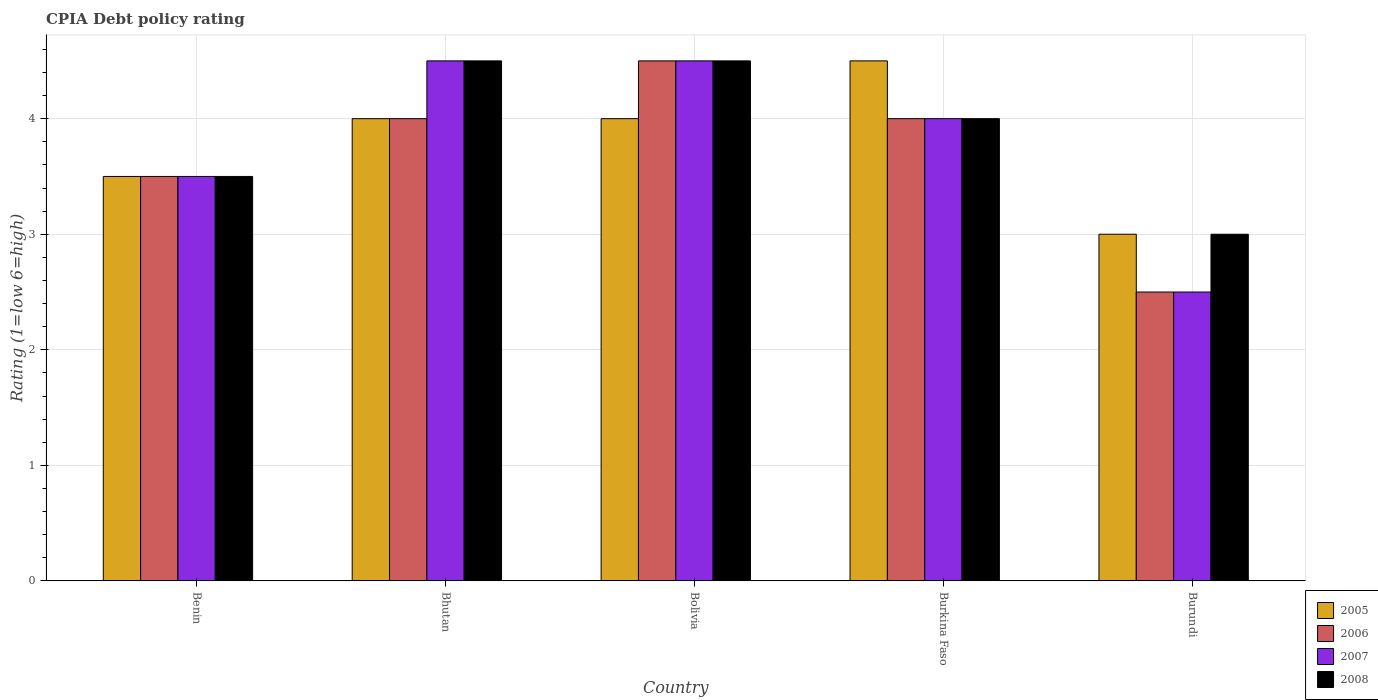How many different coloured bars are there?
Keep it short and to the point. 4. How many bars are there on the 4th tick from the right?
Provide a short and direct response. 4. What is the label of the 2nd group of bars from the left?
Ensure brevity in your answer.  Bhutan. What is the CPIA rating in 2007 in Bolivia?
Give a very brief answer. 4.5. Across all countries, what is the minimum CPIA rating in 2006?
Provide a short and direct response. 2.5. In which country was the CPIA rating in 2005 maximum?
Provide a short and direct response. Burkina Faso. In which country was the CPIA rating in 2008 minimum?
Your answer should be very brief. Burundi. What is the difference between the CPIA rating in 2005 in Bolivia and the CPIA rating in 2007 in Bhutan?
Keep it short and to the point. -0.5. In how many countries, is the CPIA rating in 2006 greater than 4.4?
Your response must be concise. 1. Is the sum of the CPIA rating in 2007 in Bolivia and Burkina Faso greater than the maximum CPIA rating in 2006 across all countries?
Offer a very short reply. Yes. What does the 4th bar from the left in Bhutan represents?
Ensure brevity in your answer.  2008. What does the 1st bar from the right in Bhutan represents?
Offer a very short reply. 2008. Is it the case that in every country, the sum of the CPIA rating in 2006 and CPIA rating in 2008 is greater than the CPIA rating in 2005?
Make the answer very short. Yes. Are all the bars in the graph horizontal?
Your answer should be very brief. No. How many countries are there in the graph?
Your answer should be compact. 5. Does the graph contain grids?
Ensure brevity in your answer.  Yes. Where does the legend appear in the graph?
Give a very brief answer. Bottom right. How many legend labels are there?
Offer a terse response. 4. How are the legend labels stacked?
Offer a very short reply. Vertical. What is the title of the graph?
Offer a very short reply. CPIA Debt policy rating. What is the label or title of the Y-axis?
Offer a very short reply. Rating (1=low 6=high). What is the Rating (1=low 6=high) of 2006 in Bhutan?
Your answer should be compact. 4. What is the Rating (1=low 6=high) in 2006 in Bolivia?
Your answer should be very brief. 4.5. What is the Rating (1=low 6=high) of 2007 in Bolivia?
Your answer should be very brief. 4.5. What is the Rating (1=low 6=high) of 2007 in Burkina Faso?
Your answer should be very brief. 4. What is the Rating (1=low 6=high) of 2008 in Burkina Faso?
Ensure brevity in your answer.  4. What is the Rating (1=low 6=high) in 2005 in Burundi?
Keep it short and to the point. 3. What is the Rating (1=low 6=high) in 2006 in Burundi?
Keep it short and to the point. 2.5. What is the Rating (1=low 6=high) in 2008 in Burundi?
Give a very brief answer. 3. Across all countries, what is the maximum Rating (1=low 6=high) in 2007?
Make the answer very short. 4.5. Across all countries, what is the maximum Rating (1=low 6=high) of 2008?
Give a very brief answer. 4.5. Across all countries, what is the minimum Rating (1=low 6=high) in 2008?
Ensure brevity in your answer.  3. What is the total Rating (1=low 6=high) of 2005 in the graph?
Your response must be concise. 19. What is the total Rating (1=low 6=high) in 2006 in the graph?
Your answer should be compact. 18.5. What is the total Rating (1=low 6=high) of 2007 in the graph?
Provide a short and direct response. 19. What is the total Rating (1=low 6=high) in 2008 in the graph?
Give a very brief answer. 19.5. What is the difference between the Rating (1=low 6=high) in 2005 in Benin and that in Bhutan?
Ensure brevity in your answer.  -0.5. What is the difference between the Rating (1=low 6=high) of 2006 in Benin and that in Bhutan?
Give a very brief answer. -0.5. What is the difference between the Rating (1=low 6=high) in 2007 in Benin and that in Bhutan?
Provide a short and direct response. -1. What is the difference between the Rating (1=low 6=high) in 2007 in Benin and that in Bolivia?
Offer a very short reply. -1. What is the difference between the Rating (1=low 6=high) of 2006 in Benin and that in Burkina Faso?
Your answer should be compact. -0.5. What is the difference between the Rating (1=low 6=high) in 2008 in Benin and that in Burkina Faso?
Offer a terse response. -0.5. What is the difference between the Rating (1=low 6=high) of 2007 in Benin and that in Burundi?
Ensure brevity in your answer.  1. What is the difference between the Rating (1=low 6=high) in 2007 in Bhutan and that in Bolivia?
Your response must be concise. 0. What is the difference between the Rating (1=low 6=high) of 2008 in Bhutan and that in Bolivia?
Provide a short and direct response. 0. What is the difference between the Rating (1=low 6=high) in 2005 in Bhutan and that in Burkina Faso?
Make the answer very short. -0.5. What is the difference between the Rating (1=low 6=high) in 2006 in Bhutan and that in Burkina Faso?
Your answer should be very brief. 0. What is the difference between the Rating (1=low 6=high) of 2005 in Bhutan and that in Burundi?
Your answer should be compact. 1. What is the difference between the Rating (1=low 6=high) of 2006 in Bhutan and that in Burundi?
Ensure brevity in your answer.  1.5. What is the difference between the Rating (1=low 6=high) of 2005 in Bolivia and that in Burkina Faso?
Offer a very short reply. -0.5. What is the difference between the Rating (1=low 6=high) of 2008 in Bolivia and that in Burkina Faso?
Your answer should be compact. 0.5. What is the difference between the Rating (1=low 6=high) of 2005 in Bolivia and that in Burundi?
Provide a succinct answer. 1. What is the difference between the Rating (1=low 6=high) in 2006 in Bolivia and that in Burundi?
Your answer should be compact. 2. What is the difference between the Rating (1=low 6=high) of 2005 in Benin and the Rating (1=low 6=high) of 2006 in Bhutan?
Make the answer very short. -0.5. What is the difference between the Rating (1=low 6=high) of 2005 in Benin and the Rating (1=low 6=high) of 2008 in Bhutan?
Make the answer very short. -1. What is the difference between the Rating (1=low 6=high) in 2006 in Benin and the Rating (1=low 6=high) in 2008 in Bhutan?
Ensure brevity in your answer.  -1. What is the difference between the Rating (1=low 6=high) of 2007 in Benin and the Rating (1=low 6=high) of 2008 in Bhutan?
Your answer should be very brief. -1. What is the difference between the Rating (1=low 6=high) of 2005 in Benin and the Rating (1=low 6=high) of 2007 in Bolivia?
Your answer should be very brief. -1. What is the difference between the Rating (1=low 6=high) in 2005 in Benin and the Rating (1=low 6=high) in 2008 in Bolivia?
Your response must be concise. -1. What is the difference between the Rating (1=low 6=high) in 2006 in Benin and the Rating (1=low 6=high) in 2008 in Bolivia?
Keep it short and to the point. -1. What is the difference between the Rating (1=low 6=high) in 2005 in Benin and the Rating (1=low 6=high) in 2006 in Burkina Faso?
Offer a terse response. -0.5. What is the difference between the Rating (1=low 6=high) in 2005 in Benin and the Rating (1=low 6=high) in 2007 in Burkina Faso?
Offer a very short reply. -0.5. What is the difference between the Rating (1=low 6=high) in 2005 in Benin and the Rating (1=low 6=high) in 2008 in Burkina Faso?
Provide a succinct answer. -0.5. What is the difference between the Rating (1=low 6=high) of 2006 in Benin and the Rating (1=low 6=high) of 2007 in Burkina Faso?
Keep it short and to the point. -0.5. What is the difference between the Rating (1=low 6=high) of 2007 in Benin and the Rating (1=low 6=high) of 2008 in Burkina Faso?
Make the answer very short. -0.5. What is the difference between the Rating (1=low 6=high) in 2005 in Benin and the Rating (1=low 6=high) in 2008 in Burundi?
Provide a short and direct response. 0.5. What is the difference between the Rating (1=low 6=high) of 2007 in Benin and the Rating (1=low 6=high) of 2008 in Burundi?
Your answer should be very brief. 0.5. What is the difference between the Rating (1=low 6=high) in 2005 in Bhutan and the Rating (1=low 6=high) in 2006 in Bolivia?
Give a very brief answer. -0.5. What is the difference between the Rating (1=low 6=high) in 2005 in Bhutan and the Rating (1=low 6=high) in 2008 in Bolivia?
Provide a short and direct response. -0.5. What is the difference between the Rating (1=low 6=high) of 2006 in Bhutan and the Rating (1=low 6=high) of 2007 in Bolivia?
Your answer should be compact. -0.5. What is the difference between the Rating (1=low 6=high) of 2006 in Bhutan and the Rating (1=low 6=high) of 2008 in Bolivia?
Your response must be concise. -0.5. What is the difference between the Rating (1=low 6=high) in 2007 in Bhutan and the Rating (1=low 6=high) in 2008 in Bolivia?
Offer a very short reply. 0. What is the difference between the Rating (1=low 6=high) of 2005 in Bhutan and the Rating (1=low 6=high) of 2006 in Burundi?
Ensure brevity in your answer.  1.5. What is the difference between the Rating (1=low 6=high) of 2005 in Bolivia and the Rating (1=low 6=high) of 2006 in Burkina Faso?
Provide a succinct answer. 0. What is the difference between the Rating (1=low 6=high) in 2005 in Bolivia and the Rating (1=low 6=high) in 2007 in Burkina Faso?
Offer a very short reply. 0. What is the difference between the Rating (1=low 6=high) of 2006 in Bolivia and the Rating (1=low 6=high) of 2008 in Burkina Faso?
Your response must be concise. 0.5. What is the difference between the Rating (1=low 6=high) in 2005 in Bolivia and the Rating (1=low 6=high) in 2006 in Burundi?
Your response must be concise. 1.5. What is the difference between the Rating (1=low 6=high) in 2005 in Bolivia and the Rating (1=low 6=high) in 2007 in Burundi?
Make the answer very short. 1.5. What is the difference between the Rating (1=low 6=high) in 2006 in Bolivia and the Rating (1=low 6=high) in 2007 in Burundi?
Keep it short and to the point. 2. What is the difference between the Rating (1=low 6=high) in 2007 in Bolivia and the Rating (1=low 6=high) in 2008 in Burundi?
Give a very brief answer. 1.5. What is the difference between the Rating (1=low 6=high) in 2005 in Burkina Faso and the Rating (1=low 6=high) in 2006 in Burundi?
Your answer should be compact. 2. What is the difference between the Rating (1=low 6=high) of 2005 in Burkina Faso and the Rating (1=low 6=high) of 2007 in Burundi?
Your answer should be very brief. 2. What is the difference between the Rating (1=low 6=high) of 2006 in Burkina Faso and the Rating (1=low 6=high) of 2007 in Burundi?
Provide a succinct answer. 1.5. What is the difference between the Rating (1=low 6=high) of 2006 in Burkina Faso and the Rating (1=low 6=high) of 2008 in Burundi?
Your answer should be compact. 1. What is the average Rating (1=low 6=high) in 2007 per country?
Keep it short and to the point. 3.8. What is the difference between the Rating (1=low 6=high) of 2005 and Rating (1=low 6=high) of 2006 in Benin?
Make the answer very short. 0. What is the difference between the Rating (1=low 6=high) of 2005 and Rating (1=low 6=high) of 2007 in Benin?
Your answer should be very brief. 0. What is the difference between the Rating (1=low 6=high) of 2005 and Rating (1=low 6=high) of 2008 in Benin?
Make the answer very short. 0. What is the difference between the Rating (1=low 6=high) in 2007 and Rating (1=low 6=high) in 2008 in Benin?
Offer a terse response. 0. What is the difference between the Rating (1=low 6=high) of 2005 and Rating (1=low 6=high) of 2007 in Bhutan?
Your answer should be very brief. -0.5. What is the difference between the Rating (1=low 6=high) in 2005 and Rating (1=low 6=high) in 2008 in Bhutan?
Your response must be concise. -0.5. What is the difference between the Rating (1=low 6=high) of 2006 and Rating (1=low 6=high) of 2007 in Bhutan?
Your answer should be very brief. -0.5. What is the difference between the Rating (1=low 6=high) of 2007 and Rating (1=low 6=high) of 2008 in Bhutan?
Your answer should be compact. 0. What is the difference between the Rating (1=low 6=high) in 2005 and Rating (1=low 6=high) in 2007 in Bolivia?
Your response must be concise. -0.5. What is the difference between the Rating (1=low 6=high) in 2006 and Rating (1=low 6=high) in 2007 in Bolivia?
Ensure brevity in your answer.  0. What is the difference between the Rating (1=low 6=high) in 2006 and Rating (1=low 6=high) in 2008 in Bolivia?
Ensure brevity in your answer.  0. What is the difference between the Rating (1=low 6=high) in 2005 and Rating (1=low 6=high) in 2007 in Burkina Faso?
Your response must be concise. 0.5. What is the difference between the Rating (1=low 6=high) in 2006 and Rating (1=low 6=high) in 2007 in Burkina Faso?
Offer a very short reply. 0. What is the difference between the Rating (1=low 6=high) of 2006 and Rating (1=low 6=high) of 2007 in Burundi?
Offer a very short reply. 0. What is the difference between the Rating (1=low 6=high) in 2006 and Rating (1=low 6=high) in 2008 in Burundi?
Keep it short and to the point. -0.5. What is the difference between the Rating (1=low 6=high) of 2007 and Rating (1=low 6=high) of 2008 in Burundi?
Your answer should be compact. -0.5. What is the ratio of the Rating (1=low 6=high) in 2005 in Benin to that in Bhutan?
Ensure brevity in your answer.  0.88. What is the ratio of the Rating (1=low 6=high) in 2006 in Benin to that in Bhutan?
Provide a succinct answer. 0.88. What is the ratio of the Rating (1=low 6=high) of 2006 in Benin to that in Bolivia?
Your answer should be very brief. 0.78. What is the ratio of the Rating (1=low 6=high) in 2007 in Benin to that in Bolivia?
Keep it short and to the point. 0.78. What is the ratio of the Rating (1=low 6=high) in 2005 in Benin to that in Burkina Faso?
Provide a succinct answer. 0.78. What is the ratio of the Rating (1=low 6=high) in 2005 in Benin to that in Burundi?
Your answer should be very brief. 1.17. What is the ratio of the Rating (1=low 6=high) in 2006 in Benin to that in Burundi?
Ensure brevity in your answer.  1.4. What is the ratio of the Rating (1=low 6=high) in 2007 in Bhutan to that in Bolivia?
Offer a terse response. 1. What is the ratio of the Rating (1=low 6=high) of 2008 in Bhutan to that in Burkina Faso?
Your answer should be compact. 1.12. What is the ratio of the Rating (1=low 6=high) of 2005 in Bhutan to that in Burundi?
Provide a short and direct response. 1.33. What is the ratio of the Rating (1=low 6=high) of 2006 in Bhutan to that in Burundi?
Offer a very short reply. 1.6. What is the ratio of the Rating (1=low 6=high) in 2008 in Bhutan to that in Burundi?
Give a very brief answer. 1.5. What is the ratio of the Rating (1=low 6=high) in 2007 in Bolivia to that in Burkina Faso?
Offer a very short reply. 1.12. What is the ratio of the Rating (1=low 6=high) in 2005 in Bolivia to that in Burundi?
Provide a short and direct response. 1.33. What is the ratio of the Rating (1=low 6=high) in 2008 in Bolivia to that in Burundi?
Your answer should be very brief. 1.5. What is the ratio of the Rating (1=low 6=high) of 2006 in Burkina Faso to that in Burundi?
Provide a short and direct response. 1.6. What is the ratio of the Rating (1=low 6=high) in 2007 in Burkina Faso to that in Burundi?
Ensure brevity in your answer.  1.6. What is the ratio of the Rating (1=low 6=high) of 2008 in Burkina Faso to that in Burundi?
Make the answer very short. 1.33. What is the difference between the highest and the second highest Rating (1=low 6=high) in 2005?
Your response must be concise. 0.5. What is the difference between the highest and the second highest Rating (1=low 6=high) of 2006?
Make the answer very short. 0.5. What is the difference between the highest and the second highest Rating (1=low 6=high) in 2007?
Ensure brevity in your answer.  0. What is the difference between the highest and the second highest Rating (1=low 6=high) in 2008?
Keep it short and to the point. 0. What is the difference between the highest and the lowest Rating (1=low 6=high) in 2007?
Ensure brevity in your answer.  2. 